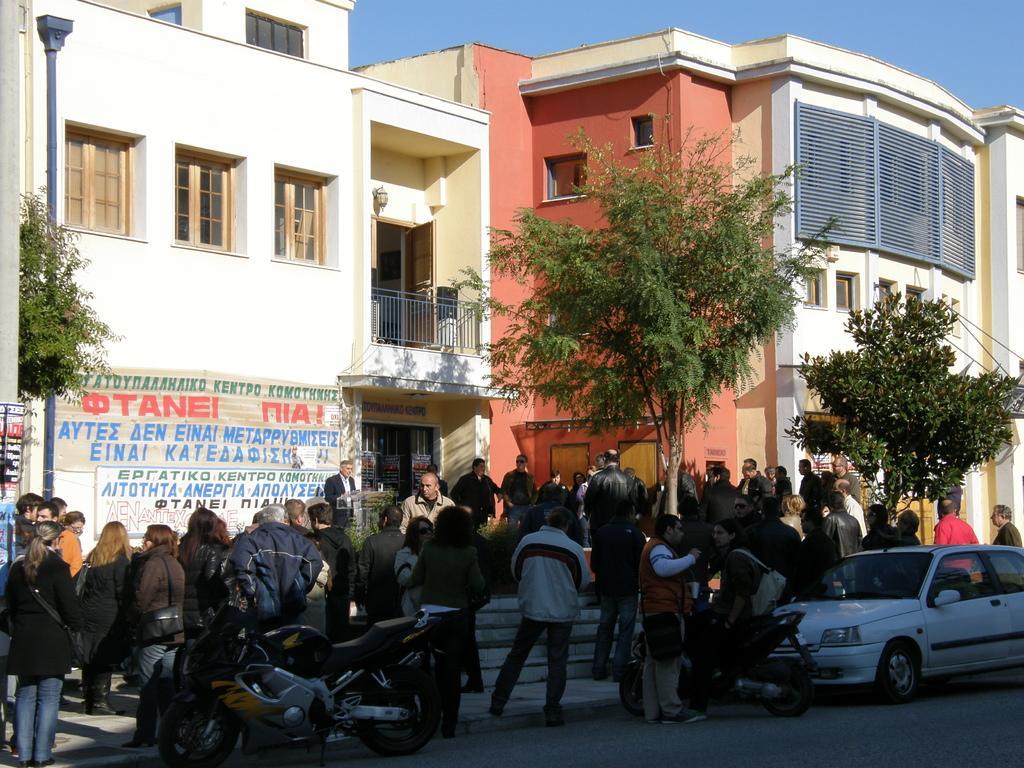Please provide a concise description of this image. This is the picture of a road. In this image there are group of people standing on the road and there is a person sitting on the motor bike. There are motorbikes and there is a car on the road. At the back there are trees and buildings and there is a pole and there are is a hoarding. At the top there is sky. At the bottom there is a road. 